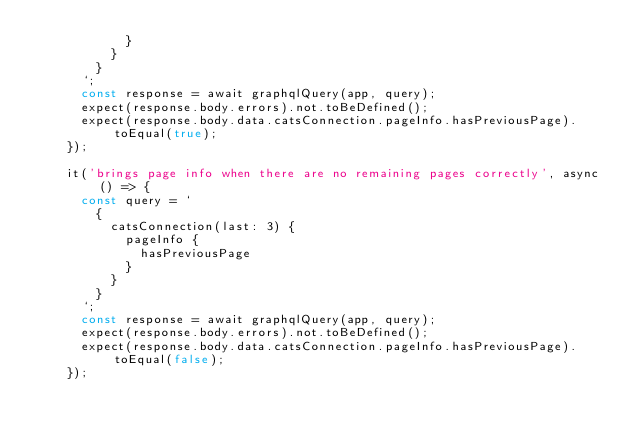Convert code to text. <code><loc_0><loc_0><loc_500><loc_500><_JavaScript_>            }
          }
        }
      `;
      const response = await graphqlQuery(app, query);
      expect(response.body.errors).not.toBeDefined();
      expect(response.body.data.catsConnection.pageInfo.hasPreviousPage).toEqual(true);
    });

    it('brings page info when there are no remaining pages correctly', async () => {
      const query = `
        {
          catsConnection(last: 3) {
            pageInfo {
              hasPreviousPage
            }
          }
        }
      `;
      const response = await graphqlQuery(app, query);
      expect(response.body.errors).not.toBeDefined();
      expect(response.body.data.catsConnection.pageInfo.hasPreviousPage).toEqual(false);
    });</code> 